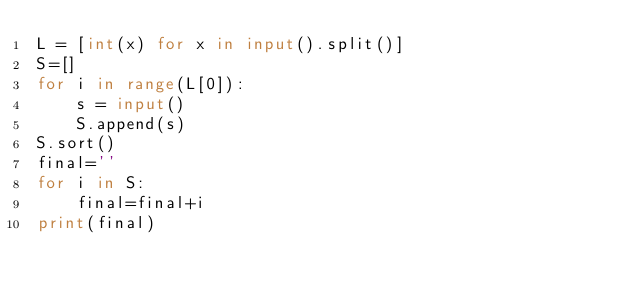<code> <loc_0><loc_0><loc_500><loc_500><_Python_>L = [int(x) for x in input().split()]
S=[]
for i in range(L[0]):
    s = input()
    S.append(s)
S.sort()
final=''
for i in S:
    final=final+i
print(final)</code> 